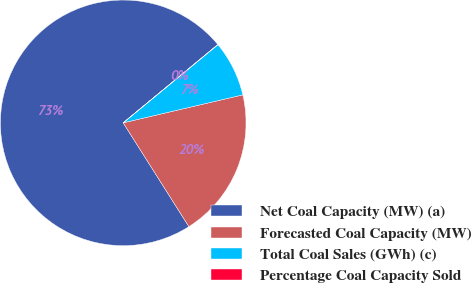<chart> <loc_0><loc_0><loc_500><loc_500><pie_chart><fcel>Net Coal Capacity (MW) (a)<fcel>Forecasted Coal Capacity (MW)<fcel>Total Coal Sales (GWh) (c)<fcel>Percentage Coal Capacity Sold<nl><fcel>72.98%<fcel>19.68%<fcel>7.32%<fcel>0.02%<nl></chart> 